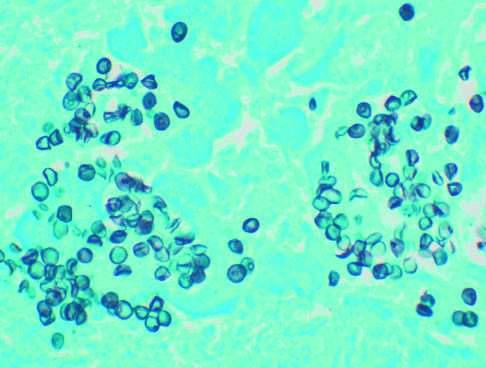does congo red staining stain demonstrate cup-shaped and round cysts within the exudate?
Answer the question using a single word or phrase. No 